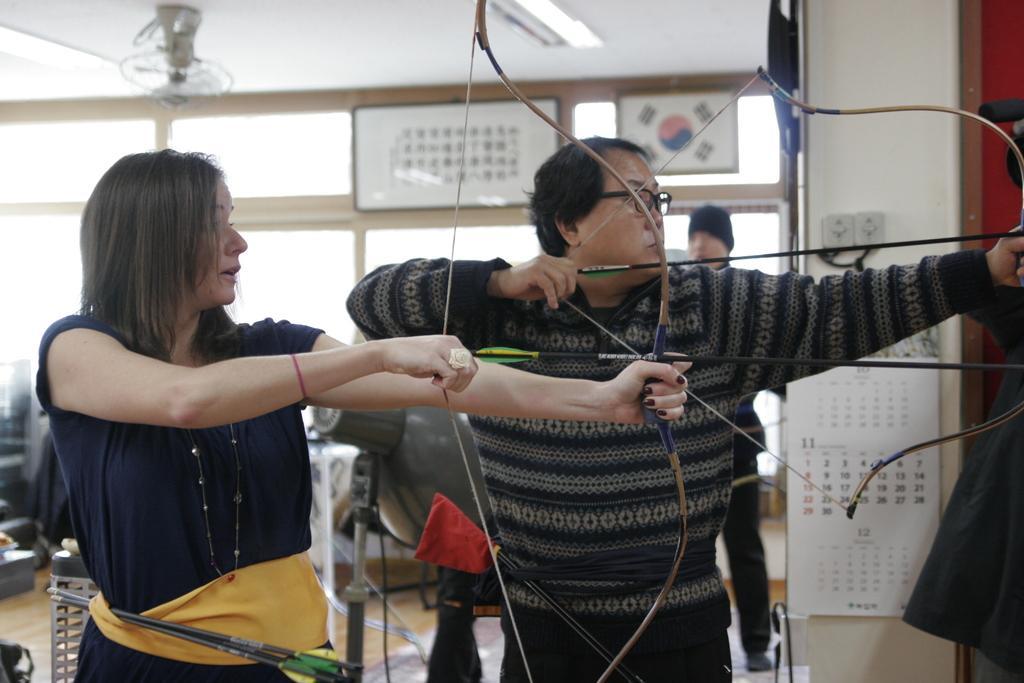In one or two sentences, can you explain what this image depicts? In this image we can see three persons, two of them are playing archery, there is a calendar, and boards on the wall, there is an object behind them, there are windows, also we can see the wall and the background is blurred. 